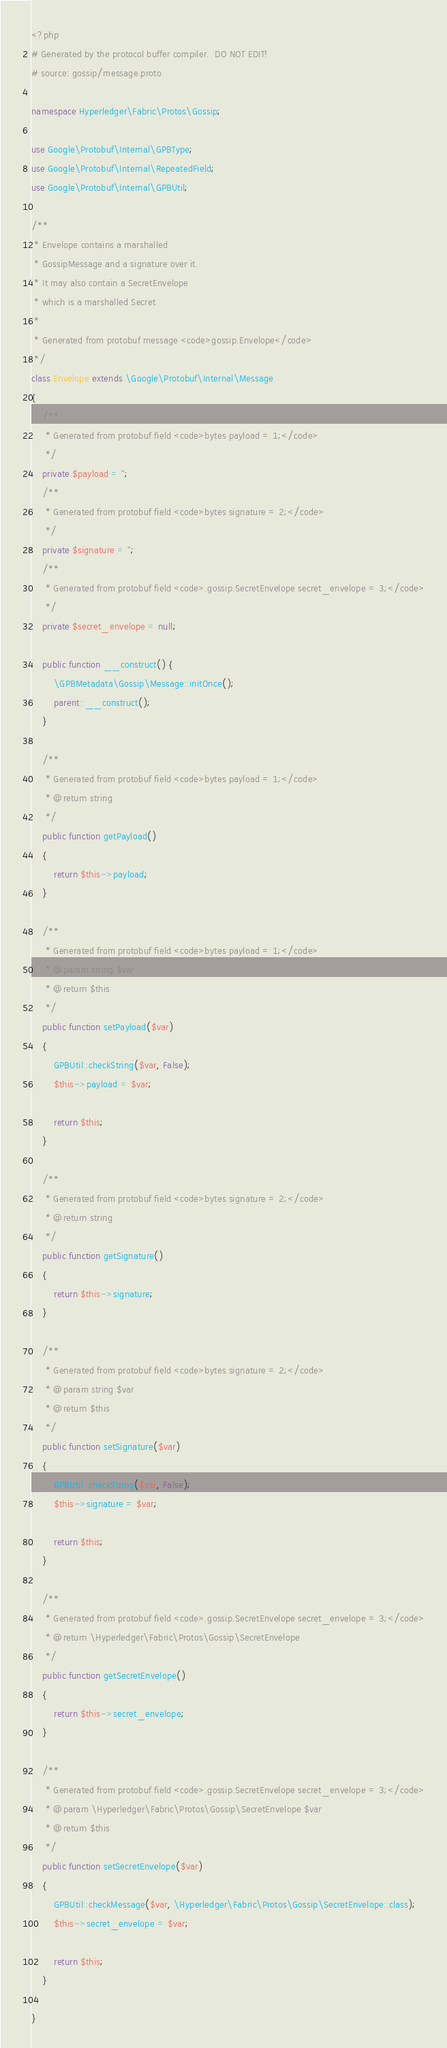<code> <loc_0><loc_0><loc_500><loc_500><_PHP_><?php
# Generated by the protocol buffer compiler.  DO NOT EDIT!
# source: gossip/message.proto

namespace Hyperledger\Fabric\Protos\Gossip;

use Google\Protobuf\Internal\GPBType;
use Google\Protobuf\Internal\RepeatedField;
use Google\Protobuf\Internal\GPBUtil;

/**
 * Envelope contains a marshalled
 * GossipMessage and a signature over it.
 * It may also contain a SecretEnvelope
 * which is a marshalled Secret
 *
 * Generated from protobuf message <code>gossip.Envelope</code>
 */
class Envelope extends \Google\Protobuf\Internal\Message
{
    /**
     * Generated from protobuf field <code>bytes payload = 1;</code>
     */
    private $payload = '';
    /**
     * Generated from protobuf field <code>bytes signature = 2;</code>
     */
    private $signature = '';
    /**
     * Generated from protobuf field <code>.gossip.SecretEnvelope secret_envelope = 3;</code>
     */
    private $secret_envelope = null;

    public function __construct() {
        \GPBMetadata\Gossip\Message::initOnce();
        parent::__construct();
    }

    /**
     * Generated from protobuf field <code>bytes payload = 1;</code>
     * @return string
     */
    public function getPayload()
    {
        return $this->payload;
    }

    /**
     * Generated from protobuf field <code>bytes payload = 1;</code>
     * @param string $var
     * @return $this
     */
    public function setPayload($var)
    {
        GPBUtil::checkString($var, False);
        $this->payload = $var;

        return $this;
    }

    /**
     * Generated from protobuf field <code>bytes signature = 2;</code>
     * @return string
     */
    public function getSignature()
    {
        return $this->signature;
    }

    /**
     * Generated from protobuf field <code>bytes signature = 2;</code>
     * @param string $var
     * @return $this
     */
    public function setSignature($var)
    {
        GPBUtil::checkString($var, False);
        $this->signature = $var;

        return $this;
    }

    /**
     * Generated from protobuf field <code>.gossip.SecretEnvelope secret_envelope = 3;</code>
     * @return \Hyperledger\Fabric\Protos\Gossip\SecretEnvelope
     */
    public function getSecretEnvelope()
    {
        return $this->secret_envelope;
    }

    /**
     * Generated from protobuf field <code>.gossip.SecretEnvelope secret_envelope = 3;</code>
     * @param \Hyperledger\Fabric\Protos\Gossip\SecretEnvelope $var
     * @return $this
     */
    public function setSecretEnvelope($var)
    {
        GPBUtil::checkMessage($var, \Hyperledger\Fabric\Protos\Gossip\SecretEnvelope::class);
        $this->secret_envelope = $var;

        return $this;
    }

}

</code> 